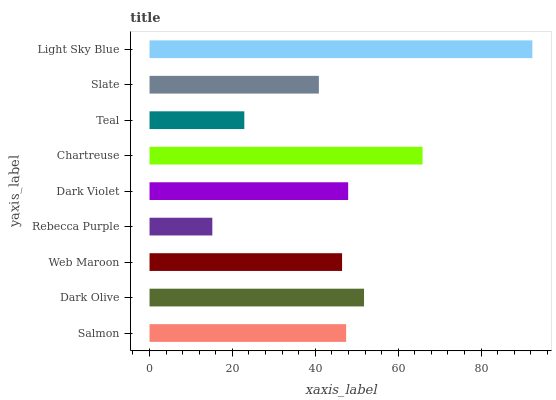Is Rebecca Purple the minimum?
Answer yes or no. Yes. Is Light Sky Blue the maximum?
Answer yes or no. Yes. Is Dark Olive the minimum?
Answer yes or no. No. Is Dark Olive the maximum?
Answer yes or no. No. Is Dark Olive greater than Salmon?
Answer yes or no. Yes. Is Salmon less than Dark Olive?
Answer yes or no. Yes. Is Salmon greater than Dark Olive?
Answer yes or no. No. Is Dark Olive less than Salmon?
Answer yes or no. No. Is Salmon the high median?
Answer yes or no. Yes. Is Salmon the low median?
Answer yes or no. Yes. Is Chartreuse the high median?
Answer yes or no. No. Is Dark Olive the low median?
Answer yes or no. No. 